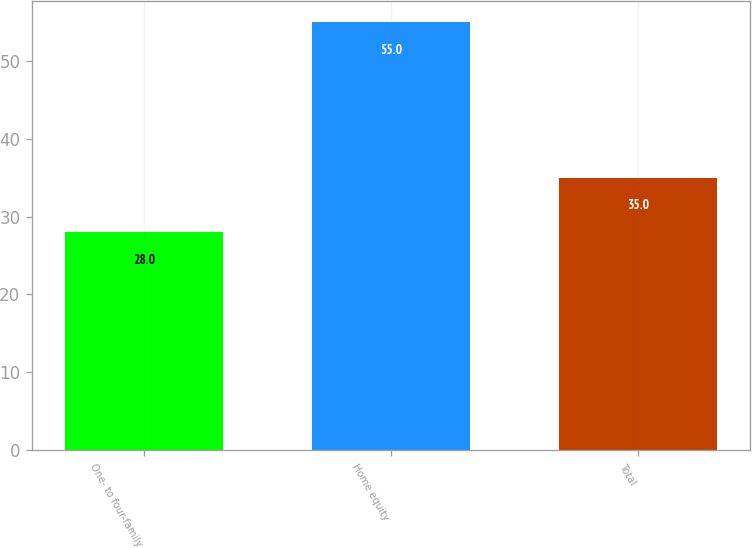Convert chart. <chart><loc_0><loc_0><loc_500><loc_500><bar_chart><fcel>One- to four-family<fcel>Home equity<fcel>Total<nl><fcel>28<fcel>55<fcel>35<nl></chart> 